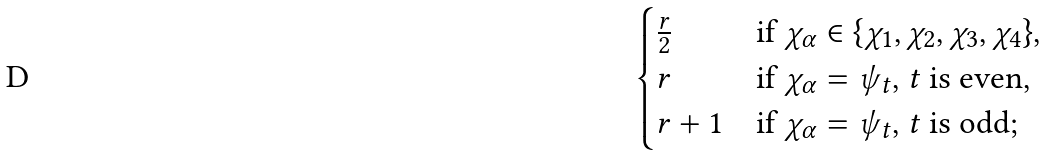Convert formula to latex. <formula><loc_0><loc_0><loc_500><loc_500>\begin{cases} \frac { r } { 2 } & \text {if $\chi_{\alpha} \in \{\chi_{1}, \chi_{2}, \chi_{3}, \chi_{4} \}$,} \\ r & \text {if $\chi_{\alpha} = \psi_{t}$, $t$ is even,} \\ r + 1 & \text {if $\chi_{\alpha} = \psi_{t}$, $t$ is odd;} \end{cases}</formula> 